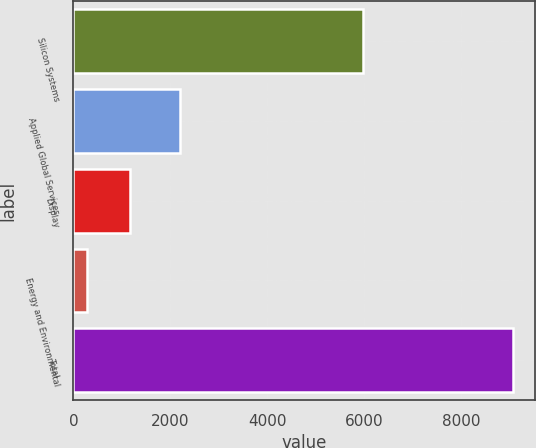Convert chart. <chart><loc_0><loc_0><loc_500><loc_500><bar_chart><fcel>Silicon Systems<fcel>Applied Global Services<fcel>Display<fcel>Energy and Environmental<fcel>Total<nl><fcel>5978<fcel>2200<fcel>1158.3<fcel>279<fcel>9072<nl></chart> 